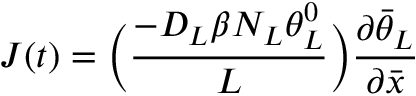<formula> <loc_0><loc_0><loc_500><loc_500>J ( t ) = \left ( \frac { - D _ { L } \beta N _ { L } \theta _ { L } ^ { 0 } } { L } \right ) \frac { \partial \bar { \theta } _ { L } } { \partial \bar { x } }</formula> 